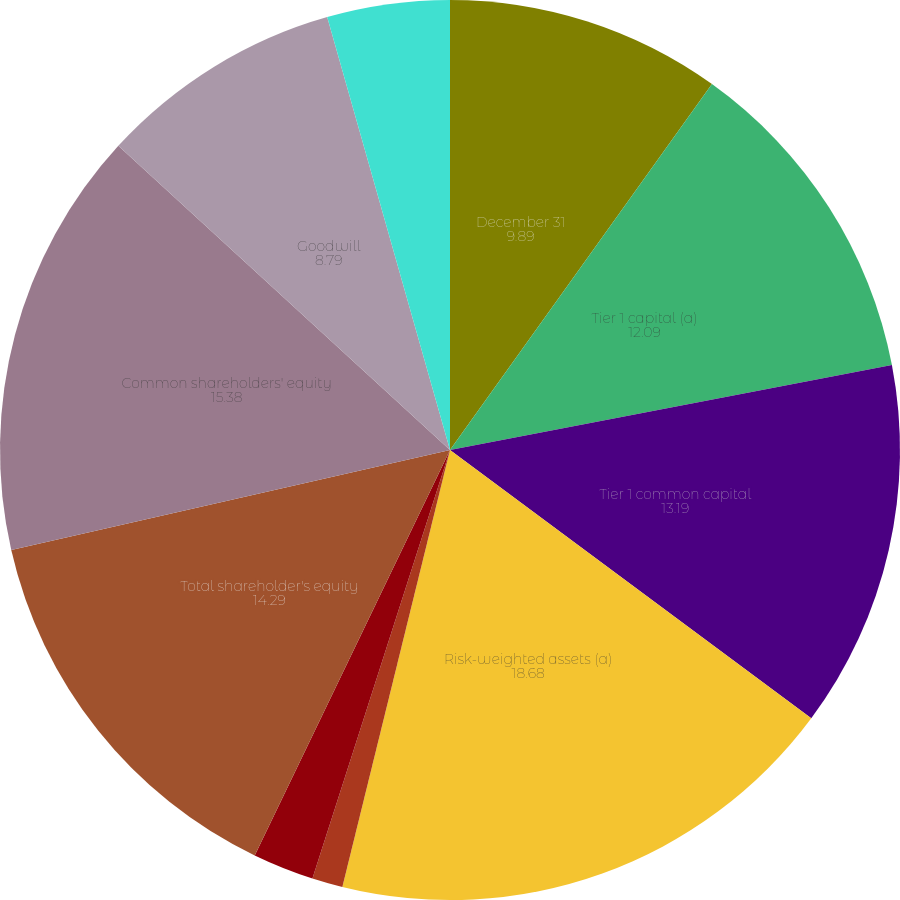Convert chart to OTSL. <chart><loc_0><loc_0><loc_500><loc_500><pie_chart><fcel>December 31<fcel>Tier 1 capital (a)<fcel>Tier 1 common capital<fcel>Risk-weighted assets (a)<fcel>Tier 1 risk-based capital<fcel>Tier 1 common capital ratio<fcel>Total shareholder's equity<fcel>Common shareholders' equity<fcel>Goodwill<fcel>Other intangible assets<nl><fcel>9.89%<fcel>12.09%<fcel>13.19%<fcel>18.68%<fcel>1.1%<fcel>2.2%<fcel>14.29%<fcel>15.38%<fcel>8.79%<fcel>4.4%<nl></chart> 